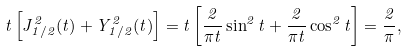<formula> <loc_0><loc_0><loc_500><loc_500>t \left [ J _ { 1 / 2 } ^ { 2 } ( t ) + Y _ { 1 / 2 } ^ { 2 } ( t ) \right ] = t \left [ \frac { 2 } { \pi t } \sin ^ { 2 } t + \frac { 2 } { \pi t } \cos ^ { 2 } t \right ] = \frac { 2 } { \pi } ,</formula> 